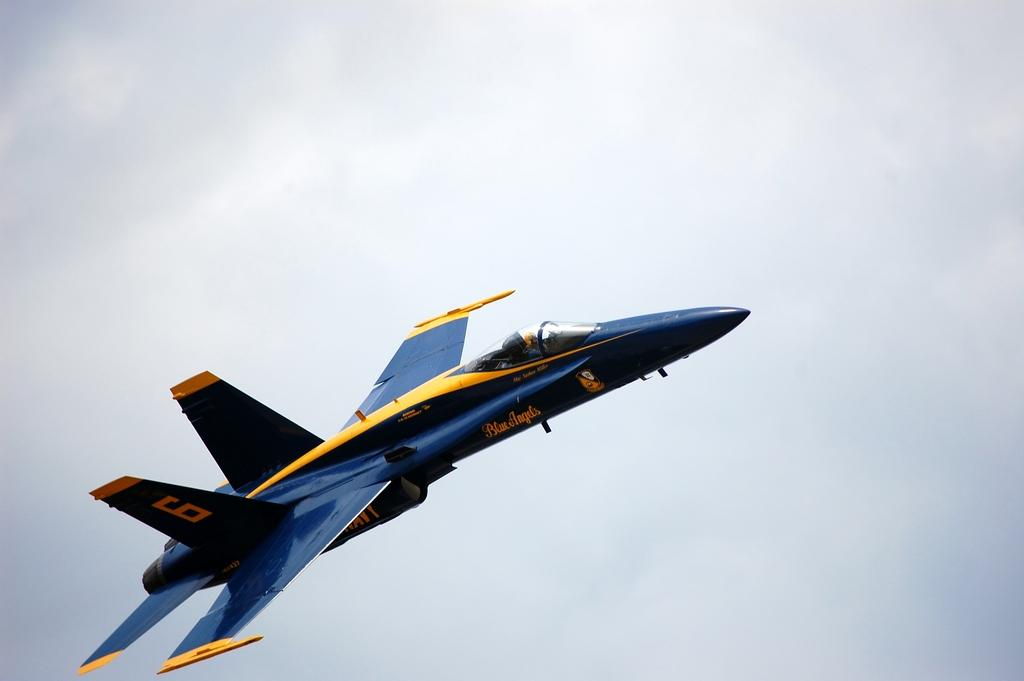What color is the airplane in the image? The airplane in the image is blue. Where is the airplane located in the image? The airplane is in the air. What can be seen in the background of the image? There are clouds and the sky visible in the background of the image. What type of cake is being served in the hall in the image? There is no hall or cake present in the image; it features a blue airplane in the air. Can you tell me where the sister is sitting in the image? There is no sister present in the image; it features a blue airplane in the air. 